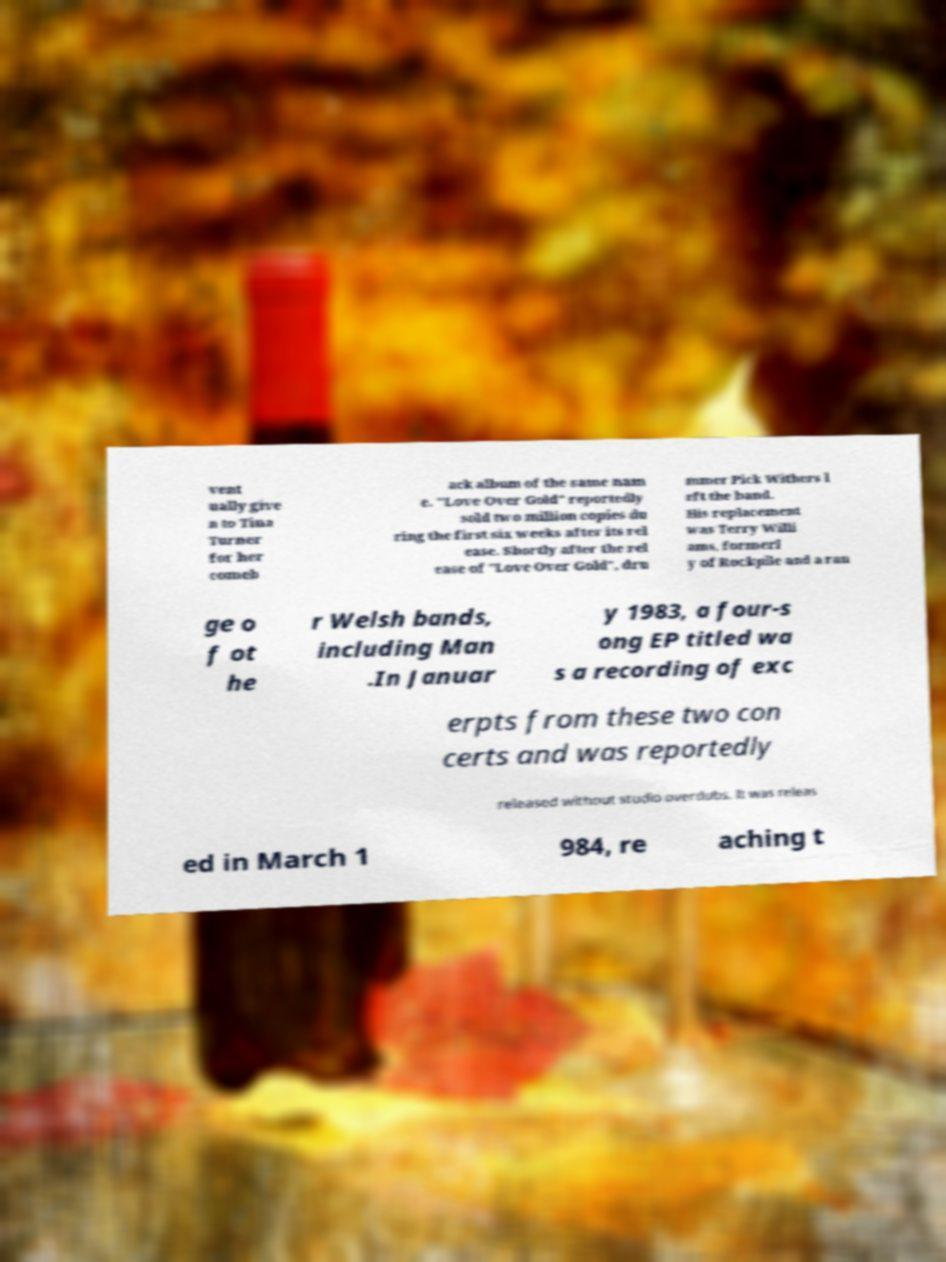What messages or text are displayed in this image? I need them in a readable, typed format. vent ually give n to Tina Turner for her comeb ack album of the same nam e. "Love Over Gold" reportedly sold two million copies du ring the first six weeks after its rel ease. Shortly after the rel ease of "Love Over Gold", dru mmer Pick Withers l eft the band. His replacement was Terry Willi ams, formerl y of Rockpile and a ran ge o f ot he r Welsh bands, including Man .In Januar y 1983, a four-s ong EP titled wa s a recording of exc erpts from these two con certs and was reportedly released without studio overdubs. It was releas ed in March 1 984, re aching t 